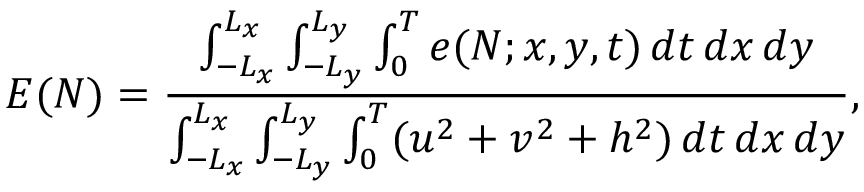<formula> <loc_0><loc_0><loc_500><loc_500>E ( N ) = \frac { \int _ { - L _ { x } } ^ { L _ { x } } \int _ { - L _ { y } } ^ { L _ { y } } \int _ { 0 } ^ { T } e ( N ; x , y , t ) \, d t \, d x \, d y } { \int _ { - L _ { x } } ^ { L _ { x } } \int _ { - L _ { y } } ^ { L _ { y } } \int _ { 0 } ^ { T } ( u ^ { 2 } + v ^ { 2 } + h ^ { 2 } ) \, d t \, d x \, d y } ,</formula> 